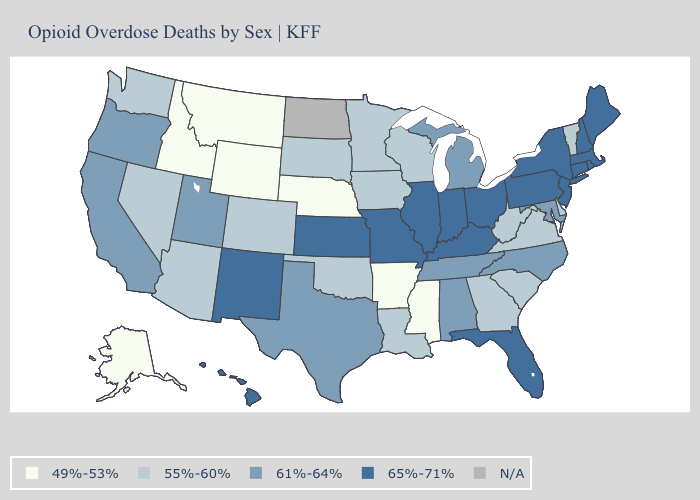Does Alabama have the lowest value in the South?
Short answer required. No. What is the lowest value in the USA?
Quick response, please. 49%-53%. What is the lowest value in the USA?
Short answer required. 49%-53%. What is the value of Alaska?
Answer briefly. 49%-53%. Does Rhode Island have the highest value in the Northeast?
Concise answer only. Yes. Which states have the lowest value in the USA?
Concise answer only. Alaska, Arkansas, Idaho, Mississippi, Montana, Nebraska, Wyoming. Name the states that have a value in the range 61%-64%?
Give a very brief answer. Alabama, California, Maryland, Michigan, North Carolina, Oregon, Tennessee, Texas, Utah. Which states have the lowest value in the USA?
Short answer required. Alaska, Arkansas, Idaho, Mississippi, Montana, Nebraska, Wyoming. Which states have the lowest value in the USA?
Concise answer only. Alaska, Arkansas, Idaho, Mississippi, Montana, Nebraska, Wyoming. Which states hav the highest value in the Northeast?
Give a very brief answer. Connecticut, Maine, Massachusetts, New Hampshire, New Jersey, New York, Pennsylvania, Rhode Island. Is the legend a continuous bar?
Give a very brief answer. No. Name the states that have a value in the range 55%-60%?
Be succinct. Arizona, Colorado, Delaware, Georgia, Iowa, Louisiana, Minnesota, Nevada, Oklahoma, South Carolina, South Dakota, Vermont, Virginia, Washington, West Virginia, Wisconsin. Does Montana have the lowest value in the West?
Give a very brief answer. Yes. What is the value of Tennessee?
Keep it brief. 61%-64%. Name the states that have a value in the range 55%-60%?
Write a very short answer. Arizona, Colorado, Delaware, Georgia, Iowa, Louisiana, Minnesota, Nevada, Oklahoma, South Carolina, South Dakota, Vermont, Virginia, Washington, West Virginia, Wisconsin. 